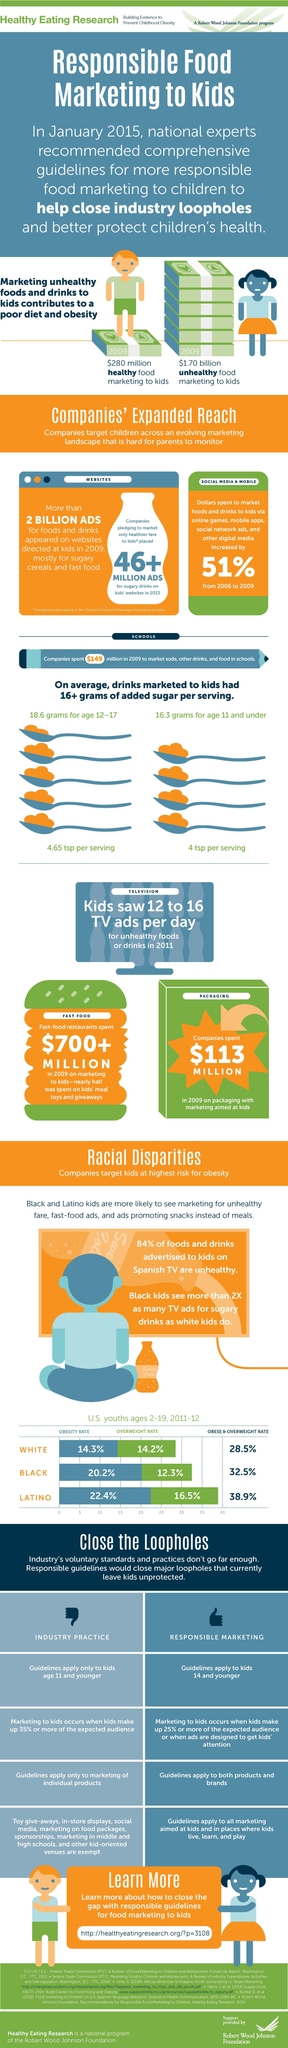Highlight a few significant elements in this photo. The rates of obesity and overweight are lower among Latinos compared to black individuals, with a respective difference of 6.4%. The difference between the obese and overweight rates in black and white individuals is 4%. A recent study found that only 16% of the food and drinks advertised to children on Spanish television are considered healthy. 